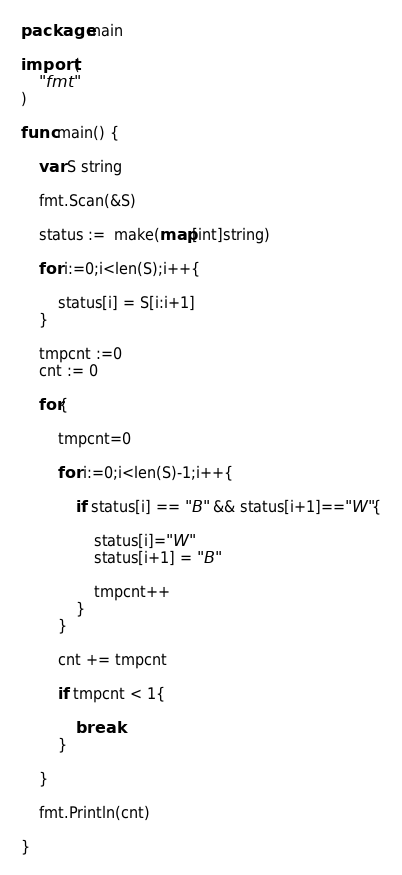Convert code to text. <code><loc_0><loc_0><loc_500><loc_500><_Go_>package main

import (
	"fmt"
)

func main() {

	var S string

	fmt.Scan(&S)

	status :=  make(map[int]string)

	for i:=0;i<len(S);i++{

		status[i] = S[i:i+1]
	}

	tmpcnt :=0
	cnt := 0

	for{

		tmpcnt=0

		for i:=0;i<len(S)-1;i++{

			if status[i] == "B" && status[i+1]=="W"{

				status[i]="W"
				status[i+1] = "B"
			
				tmpcnt++
			}
		}

		cnt += tmpcnt

		if tmpcnt < 1{

			break
		}

	}

	fmt.Println(cnt)

}</code> 